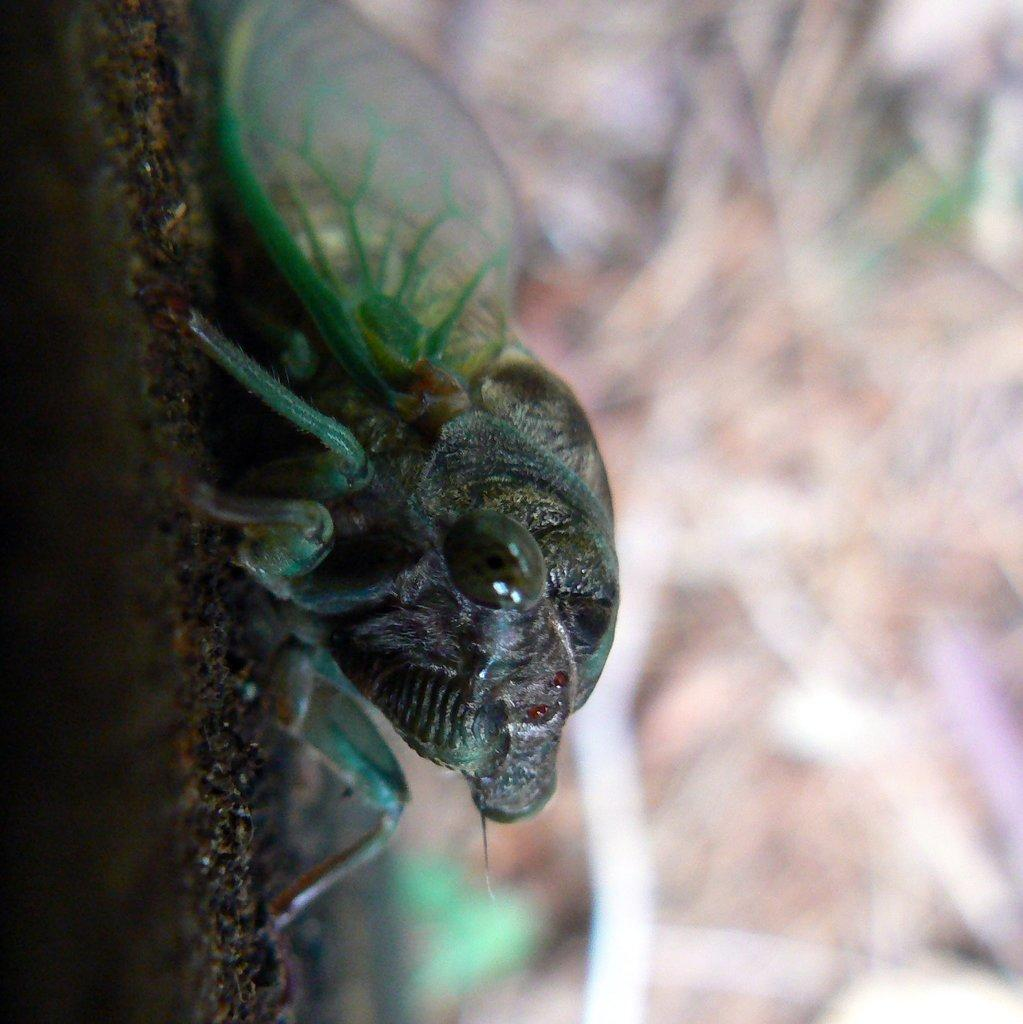What type of creature can be seen in the image? There is an insect in the image. What color is the coat worn by the insect in the image? There is no coat present in the image, as insects do not wear clothing. 